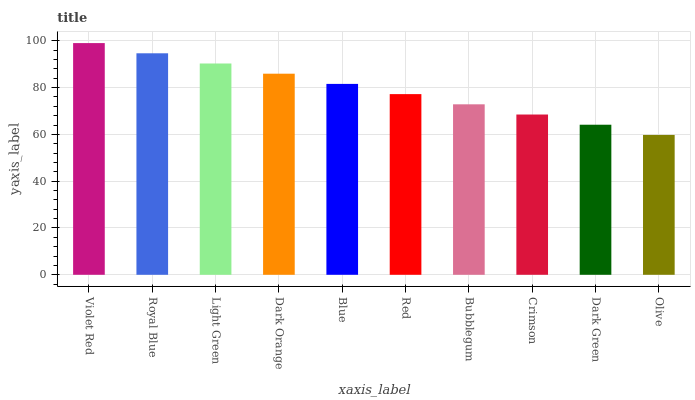Is Olive the minimum?
Answer yes or no. Yes. Is Violet Red the maximum?
Answer yes or no. Yes. Is Royal Blue the minimum?
Answer yes or no. No. Is Royal Blue the maximum?
Answer yes or no. No. Is Violet Red greater than Royal Blue?
Answer yes or no. Yes. Is Royal Blue less than Violet Red?
Answer yes or no. Yes. Is Royal Blue greater than Violet Red?
Answer yes or no. No. Is Violet Red less than Royal Blue?
Answer yes or no. No. Is Blue the high median?
Answer yes or no. Yes. Is Red the low median?
Answer yes or no. Yes. Is Light Green the high median?
Answer yes or no. No. Is Crimson the low median?
Answer yes or no. No. 